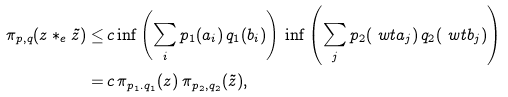Convert formula to latex. <formula><loc_0><loc_0><loc_500><loc_500>\pi _ { p , q } ( z * _ { e } \tilde { z } ) \leq & \, c \inf \left ( \sum _ { i } p _ { 1 } ( a _ { i } ) \, q _ { 1 } ( b _ { i } ) \right ) \, \inf \left ( \sum _ { j } p _ { 2 } ( \ w t { a } _ { j } ) \, q _ { 2 } ( \ w t { b } _ { j } ) \right ) \\ = & \, c \, \pi _ { p _ { 1 } . q _ { 1 } } ( z ) \, \pi _ { p _ { 2 } , q _ { 2 } } ( \tilde { z } ) ,</formula> 